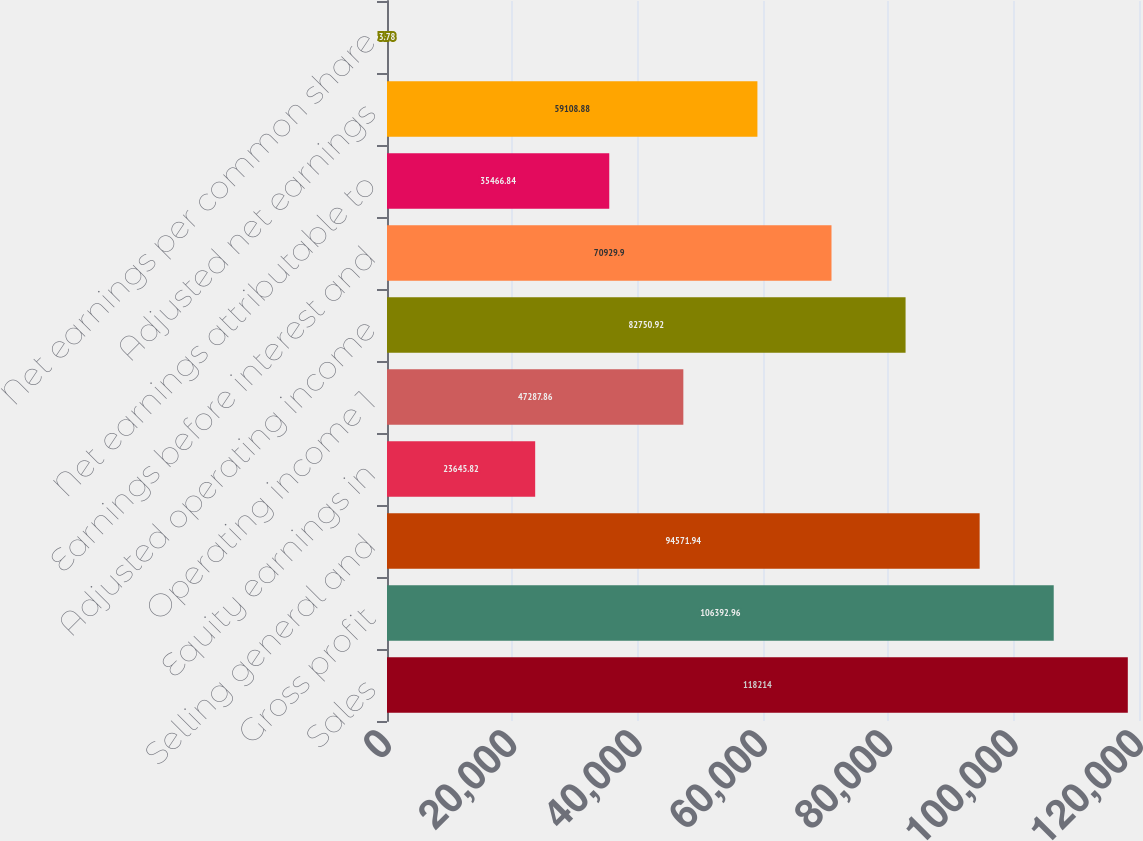<chart> <loc_0><loc_0><loc_500><loc_500><bar_chart><fcel>Sales<fcel>Gross profit<fcel>Selling general and<fcel>Equity earnings in<fcel>Operating income 1<fcel>Adjusted operating income<fcel>Earnings before interest and<fcel>Net earnings attributable to<fcel>Adjusted net earnings<fcel>Net earnings per common share<nl><fcel>118214<fcel>106393<fcel>94571.9<fcel>23645.8<fcel>47287.9<fcel>82750.9<fcel>70929.9<fcel>35466.8<fcel>59108.9<fcel>3.78<nl></chart> 